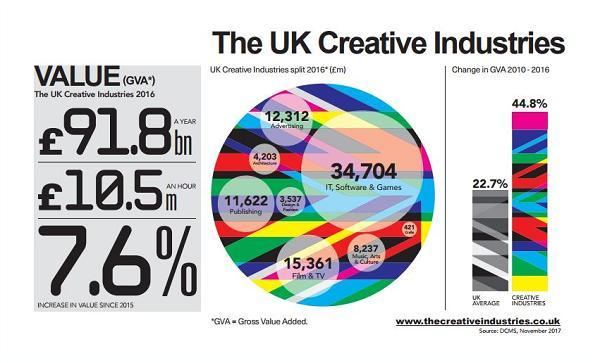What is the percentage of increase in value since 2015?
Answer the question with a short phrase. 7.6% What contributed £91.8bn of value to the UK economy in 2016? Creative Industries What was the GVA for publishing sector in 2016? 11,622 What was the GVA for IT, software and games sector in 2016? 34,704 